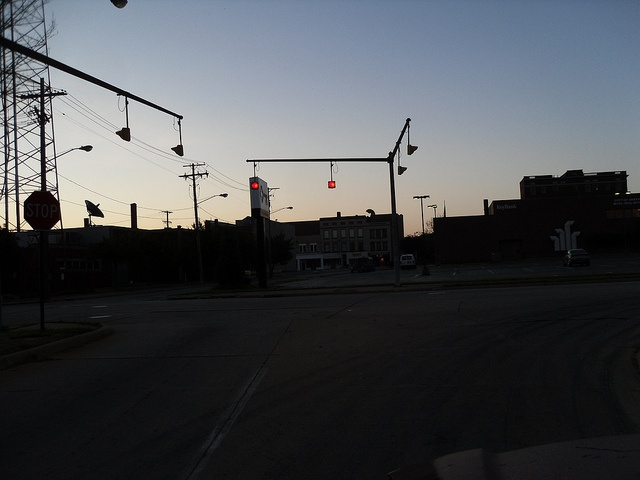Describe the objects in this image and their specific colors. I can see stop sign in black and gray tones, traffic light in black, gray, maroon, and red tones, car in black and gray tones, car in black tones, and traffic light in black, lightgray, darkgray, and gray tones in this image. 